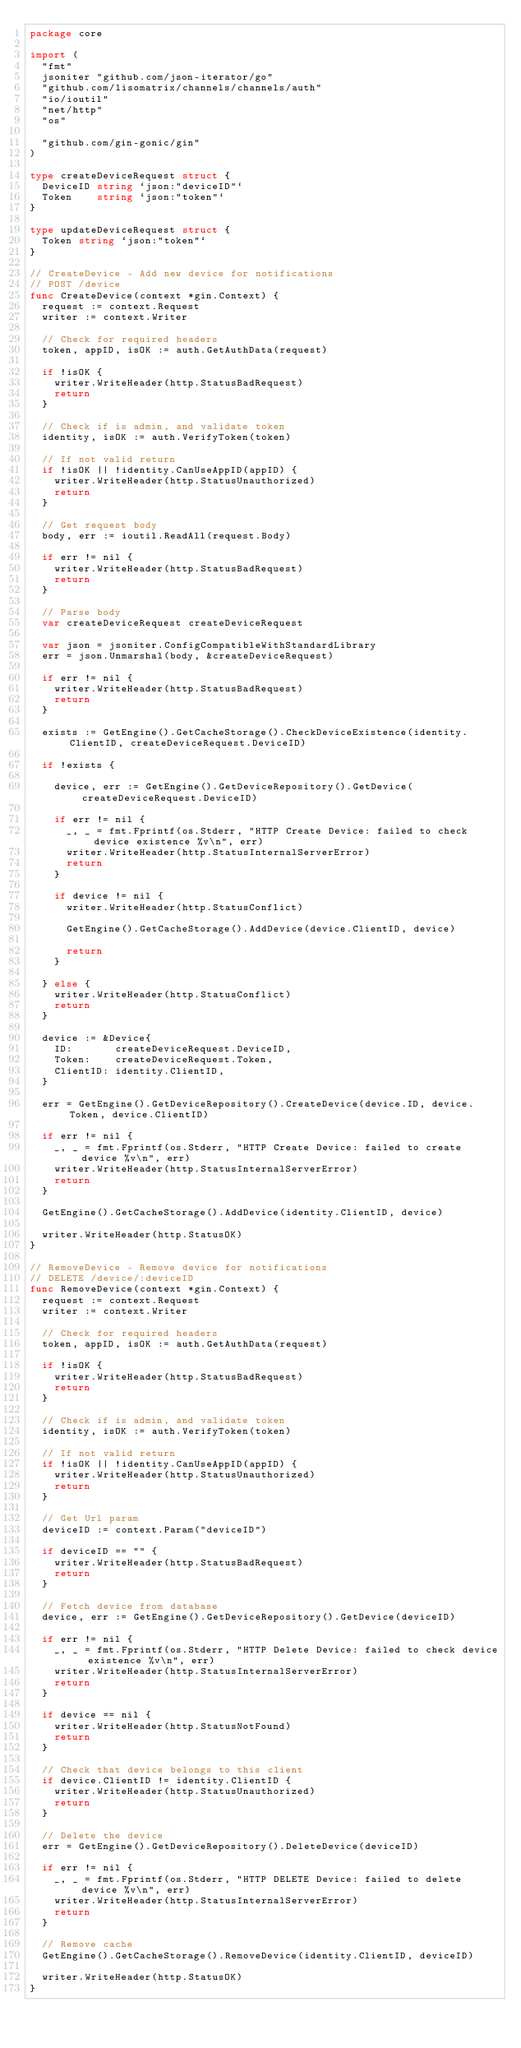Convert code to text. <code><loc_0><loc_0><loc_500><loc_500><_Go_>package core

import (
	"fmt"
	jsoniter "github.com/json-iterator/go"
	"github.com/lisomatrix/channels/channels/auth"
	"io/ioutil"
	"net/http"
	"os"

	"github.com/gin-gonic/gin"
)

type createDeviceRequest struct {
	DeviceID string `json:"deviceID"`
	Token    string `json:"token"`
}

type updateDeviceRequest struct {
	Token string `json:"token"`
}

// CreateDevice - Add new device for notifications
// POST /device
func CreateDevice(context *gin.Context) {
	request := context.Request
	writer := context.Writer

	// Check for required headers
	token, appID, isOK := auth.GetAuthData(request)

	if !isOK {
		writer.WriteHeader(http.StatusBadRequest)
		return
	}

	// Check if is admin, and validate token
	identity, isOK := auth.VerifyToken(token)

	// If not valid return
	if !isOK || !identity.CanUseAppID(appID) {
		writer.WriteHeader(http.StatusUnauthorized)
		return
	}

	// Get request body
	body, err := ioutil.ReadAll(request.Body)

	if err != nil {
		writer.WriteHeader(http.StatusBadRequest)
		return
	}

	// Parse body
	var createDeviceRequest createDeviceRequest

	var json = jsoniter.ConfigCompatibleWithStandardLibrary
	err = json.Unmarshal(body, &createDeviceRequest)

	if err != nil {
		writer.WriteHeader(http.StatusBadRequest)
		return
	}

	exists := GetEngine().GetCacheStorage().CheckDeviceExistence(identity.ClientID, createDeviceRequest.DeviceID)

	if !exists {

		device, err := GetEngine().GetDeviceRepository().GetDevice(createDeviceRequest.DeviceID)

		if err != nil {
			_, _ = fmt.Fprintf(os.Stderr, "HTTP Create Device: failed to check device existence %v\n", err)
			writer.WriteHeader(http.StatusInternalServerError)
			return
		}

		if device != nil {
			writer.WriteHeader(http.StatusConflict)

			GetEngine().GetCacheStorage().AddDevice(device.ClientID, device)

			return
		}

	} else {
		writer.WriteHeader(http.StatusConflict)
		return
	}

	device := &Device{
		ID:       createDeviceRequest.DeviceID,
		Token:    createDeviceRequest.Token,
		ClientID: identity.ClientID,
	}

	err = GetEngine().GetDeviceRepository().CreateDevice(device.ID, device.Token, device.ClientID)

	if err != nil {
		_, _ = fmt.Fprintf(os.Stderr, "HTTP Create Device: failed to create device %v\n", err)
		writer.WriteHeader(http.StatusInternalServerError)
		return
	}

	GetEngine().GetCacheStorage().AddDevice(identity.ClientID, device)

	writer.WriteHeader(http.StatusOK)
}

// RemoveDevice - Remove device for notifications
// DELETE /device/:deviceID
func RemoveDevice(context *gin.Context) {
	request := context.Request
	writer := context.Writer

	// Check for required headers
	token, appID, isOK := auth.GetAuthData(request)

	if !isOK {
		writer.WriteHeader(http.StatusBadRequest)
		return
	}

	// Check if is admin, and validate token
	identity, isOK := auth.VerifyToken(token)

	// If not valid return
	if !isOK || !identity.CanUseAppID(appID) {
		writer.WriteHeader(http.StatusUnauthorized)
		return
	}

	// Get Url param
	deviceID := context.Param("deviceID")

	if deviceID == "" {
		writer.WriteHeader(http.StatusBadRequest)
		return
	}

	// Fetch device from database
	device, err := GetEngine().GetDeviceRepository().GetDevice(deviceID)

	if err != nil {
		_, _ = fmt.Fprintf(os.Stderr, "HTTP Delete Device: failed to check device existence %v\n", err)
		writer.WriteHeader(http.StatusInternalServerError)
		return
	}

	if device == nil {
		writer.WriteHeader(http.StatusNotFound)
		return
	}

	// Check that device belongs to this client
	if device.ClientID != identity.ClientID {
		writer.WriteHeader(http.StatusUnauthorized)
		return
	}

	// Delete the device
	err = GetEngine().GetDeviceRepository().DeleteDevice(deviceID)

	if err != nil {
		_, _ = fmt.Fprintf(os.Stderr, "HTTP DELETE Device: failed to delete device %v\n", err)
		writer.WriteHeader(http.StatusInternalServerError)
		return
	}

	// Remove cache
	GetEngine().GetCacheStorage().RemoveDevice(identity.ClientID, deviceID)

	writer.WriteHeader(http.StatusOK)
}
</code> 